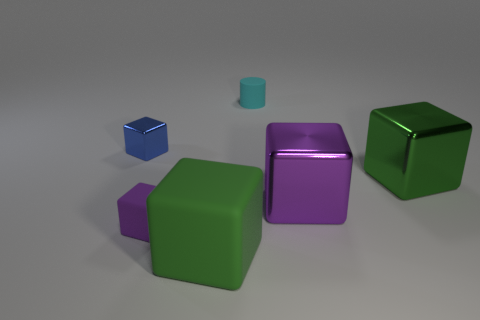Subtract all blue cubes. How many cubes are left? 4 Subtract 2 blocks. How many blocks are left? 3 Subtract all purple rubber cubes. How many cubes are left? 4 Subtract all yellow blocks. Subtract all blue balls. How many blocks are left? 5 Add 2 small blocks. How many objects exist? 8 Subtract all cubes. How many objects are left? 1 Subtract all big green cubes. Subtract all small purple objects. How many objects are left? 3 Add 3 tiny metal things. How many tiny metal things are left? 4 Add 2 small cyan balls. How many small cyan balls exist? 2 Subtract 0 red blocks. How many objects are left? 6 